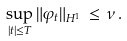<formula> <loc_0><loc_0><loc_500><loc_500>\sup _ { | t | \leq T } \| \varphi _ { t } \| _ { H ^ { 1 } } \, \leq \, \nu \, .</formula> 